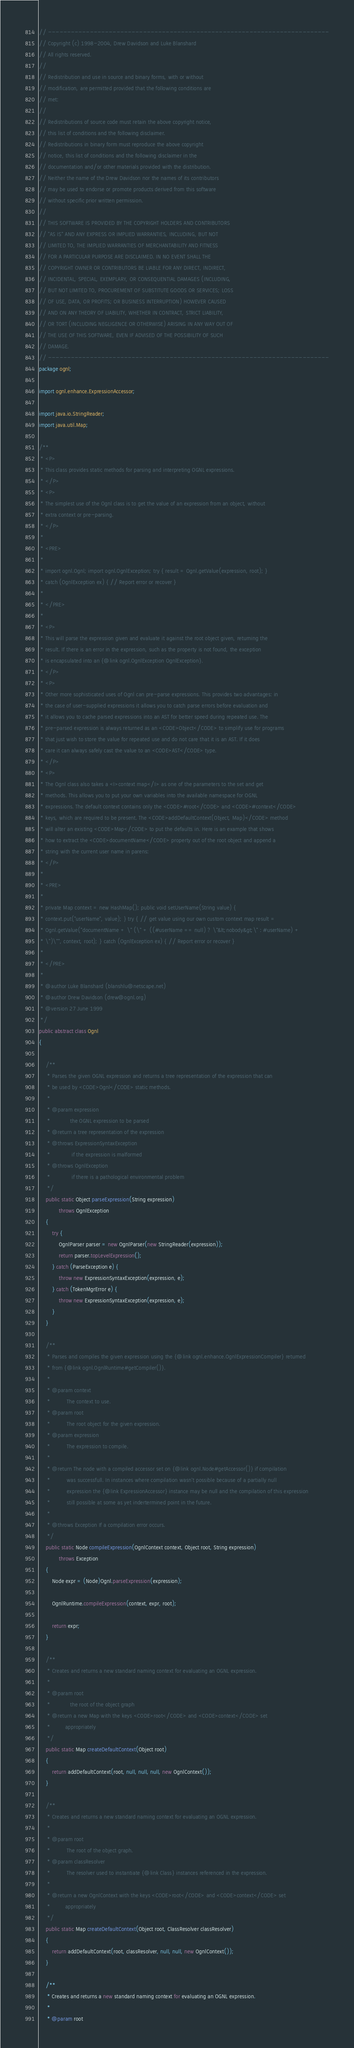Convert code to text. <code><loc_0><loc_0><loc_500><loc_500><_Java_>// --------------------------------------------------------------------------
// Copyright (c) 1998-2004, Drew Davidson and Luke Blanshard
// All rights reserved.
//
// Redistribution and use in source and binary forms, with or without
// modification, are permitted provided that the following conditions are
// met:
//
// Redistributions of source code must retain the above copyright notice,
// this list of conditions and the following disclaimer.
// Redistributions in binary form must reproduce the above copyright
// notice, this list of conditions and the following disclaimer in the
// documentation and/or other materials provided with the distribution.
// Neither the name of the Drew Davidson nor the names of its contributors
// may be used to endorse or promote products derived from this software
// without specific prior written permission.
//
// THIS SOFTWARE IS PROVIDED BY THE COPYRIGHT HOLDERS AND CONTRIBUTORS
// "AS IS" AND ANY EXPRESS OR IMPLIED WARRANTIES, INCLUDING, BUT NOT
// LIMITED TO, THE IMPLIED WARRANTIES OF MERCHANTABILITY AND FITNESS
// FOR A PARTICULAR PURPOSE ARE DISCLAIMED. IN NO EVENT SHALL THE
// COPYRIGHT OWNER OR CONTRIBUTORS BE LIABLE FOR ANY DIRECT, INDIRECT,
// INCIDENTAL, SPECIAL, EXEMPLARY, OR CONSEQUENTIAL DAMAGES (INCLUDING,
// BUT NOT LIMITED TO, PROCUREMENT OF SUBSTITUTE GOODS OR SERVICES; LOSS
// OF USE, DATA, OR PROFITS; OR BUSINESS INTERRUPTION) HOWEVER CAUSED
// AND ON ANY THEORY OF LIABILITY, WHETHER IN CONTRACT, STRICT LIABILITY,
// OR TORT (INCLUDING NEGLIGENCE OR OTHERWISE) ARISING IN ANY WAY OUT OF
// THE USE OF THIS SOFTWARE, EVEN IF ADVISED OF THE POSSIBILITY OF SUCH
// DAMAGE.
// --------------------------------------------------------------------------
package ognl;

import ognl.enhance.ExpressionAccessor;

import java.io.StringReader;
import java.util.Map;

/**
 * <P>
 * This class provides static methods for parsing and interpreting OGNL expressions.
 * </P>
 * <P>
 * The simplest use of the Ognl class is to get the value of an expression from an object, without
 * extra context or pre-parsing.
 * </P>
 *
 * <PRE>
 *
 * import ognl.Ognl; import ognl.OgnlException; try { result = Ognl.getValue(expression, root); }
 * catch (OgnlException ex) { // Report error or recover }
 *
 * </PRE>
 *
 * <P>
 * This will parse the expression given and evaluate it against the root object given, returning the
 * result. If there is an error in the expression, such as the property is not found, the exception
 * is encapsulated into an {@link ognl.OgnlException OgnlException}.
 * </P>
 * <P>
 * Other more sophisticated uses of Ognl can pre-parse expressions. This provides two advantages: in
 * the case of user-supplied expressions it allows you to catch parse errors before evaluation and
 * it allows you to cache parsed expressions into an AST for better speed during repeated use. The
 * pre-parsed expression is always returned as an <CODE>Object</CODE> to simplify use for programs
 * that just wish to store the value for repeated use and do not care that it is an AST. If it does
 * care it can always safely cast the value to an <CODE>AST</CODE> type.
 * </P>
 * <P>
 * The Ognl class also takes a <I>context map</I> as one of the parameters to the set and get
 * methods. This allows you to put your own variables into the available namespace for OGNL
 * expressions. The default context contains only the <CODE>#root</CODE> and <CODE>#context</CODE>
 * keys, which are required to be present. The <CODE>addDefaultContext(Object, Map)</CODE> method
 * will alter an existing <CODE>Map</CODE> to put the defaults in. Here is an example that shows
 * how to extract the <CODE>documentName</CODE> property out of the root object and append a
 * string with the current user name in parens:
 * </P>
 *
 * <PRE>
 *
 * private Map context = new HashMap(); public void setUserName(String value) {
 * context.put("userName", value); } try { // get value using our own custom context map result =
 * Ognl.getValue("documentName + \" (\" + ((#userName == null) ? \"&lt;nobody&gt;\" : #userName) +
 * \")\"", context, root); } catch (OgnlException ex) { // Report error or recover }
 *
 * </PRE>
 *
 * @author Luke Blanshard (blanshlu@netscape.net)
 * @author Drew Davidson (drew@ognl.org)
 * @version 27 June 1999
 */
public abstract class Ognl
{

    /**
     * Parses the given OGNL expression and returns a tree representation of the expression that can
     * be used by <CODE>Ognl</CODE> static methods.
     *
     * @param expression
     *            the OGNL expression to be parsed
     * @return a tree representation of the expression
     * @throws ExpressionSyntaxException
     *             if the expression is malformed
     * @throws OgnlException
     *             if there is a pathological environmental problem
     */
    public static Object parseExpression(String expression)
            throws OgnlException
    {
        try {
            OgnlParser parser = new OgnlParser(new StringReader(expression));
            return parser.topLevelExpression();
        } catch (ParseException e) {
            throw new ExpressionSyntaxException(expression, e);
        } catch (TokenMgrError e) {
            throw new ExpressionSyntaxException(expression, e);
        }
    }

    /**
     * Parses and compiles the given expression using the {@link ognl.enhance.OgnlExpressionCompiler} returned
     * from {@link ognl.OgnlRuntime#getCompiler()}.
     *
     * @param context
     *          The context to use.
     * @param root
     *          The root object for the given expression.
     * @param expression
     *          The expression to compile.
     *
     * @return The node with a compiled accessor set on {@link ognl.Node#getAccessor()} if compilation
     *          was successfull. In instances where compilation wasn't possible because of a partially null
     *          expression the {@link ExpressionAccessor} instance may be null and the compilation of this expression
     *          still possible at some as yet indertermined point in the future.
     *
     * @throws Exception If a compilation error occurs.
     */
    public static Node compileExpression(OgnlContext context, Object root, String expression)
            throws Exception
    {
        Node expr = (Node)Ognl.parseExpression(expression);

        OgnlRuntime.compileExpression(context, expr, root);

        return expr;
    }

    /**
     * Creates and returns a new standard naming context for evaluating an OGNL expression.
     *
     * @param root
     *            the root of the object graph
     * @return a new Map with the keys <CODE>root</CODE> and <CODE>context</CODE> set
     *         appropriately
     */
    public static Map createDefaultContext(Object root)
    {
        return addDefaultContext(root, null, null, null, new OgnlContext());
    }

    /**
     * Creates and returns a new standard naming context for evaluating an OGNL expression.
     *
     * @param root
     *          The root of the object graph.
     * @param classResolver
     *          The resolver used to instantiate {@link Class} instances referenced in the expression.
     *
     * @return a new OgnlContext with the keys <CODE>root</CODE> and <CODE>context</CODE> set
     *         appropriately
     */
    public static Map createDefaultContext(Object root, ClassResolver classResolver)
    {
        return addDefaultContext(root, classResolver, null, null, new OgnlContext());
    }

    /**
     * Creates and returns a new standard naming context for evaluating an OGNL expression.
     *
     * @param root</code> 